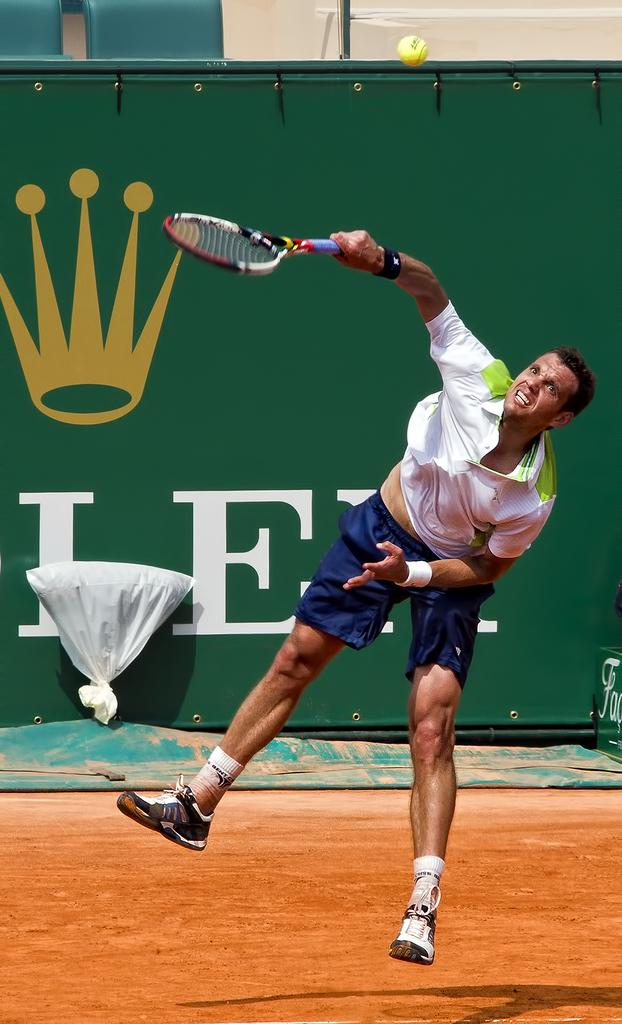What type of person can be seen in the image? There is a sports person in the image. What is the sports person wearing? The sports person is wearing a white T-shirt. What object is the sports person holding in his hand? The sports person is holding a racket in his hand. What other object is visible in the image? There is a ball visible at the top of the image. What type of pet can be seen in the image? There is no pet visible in the image. Is there a cable attached to the racket in the image? There is no cable visible in the image. 